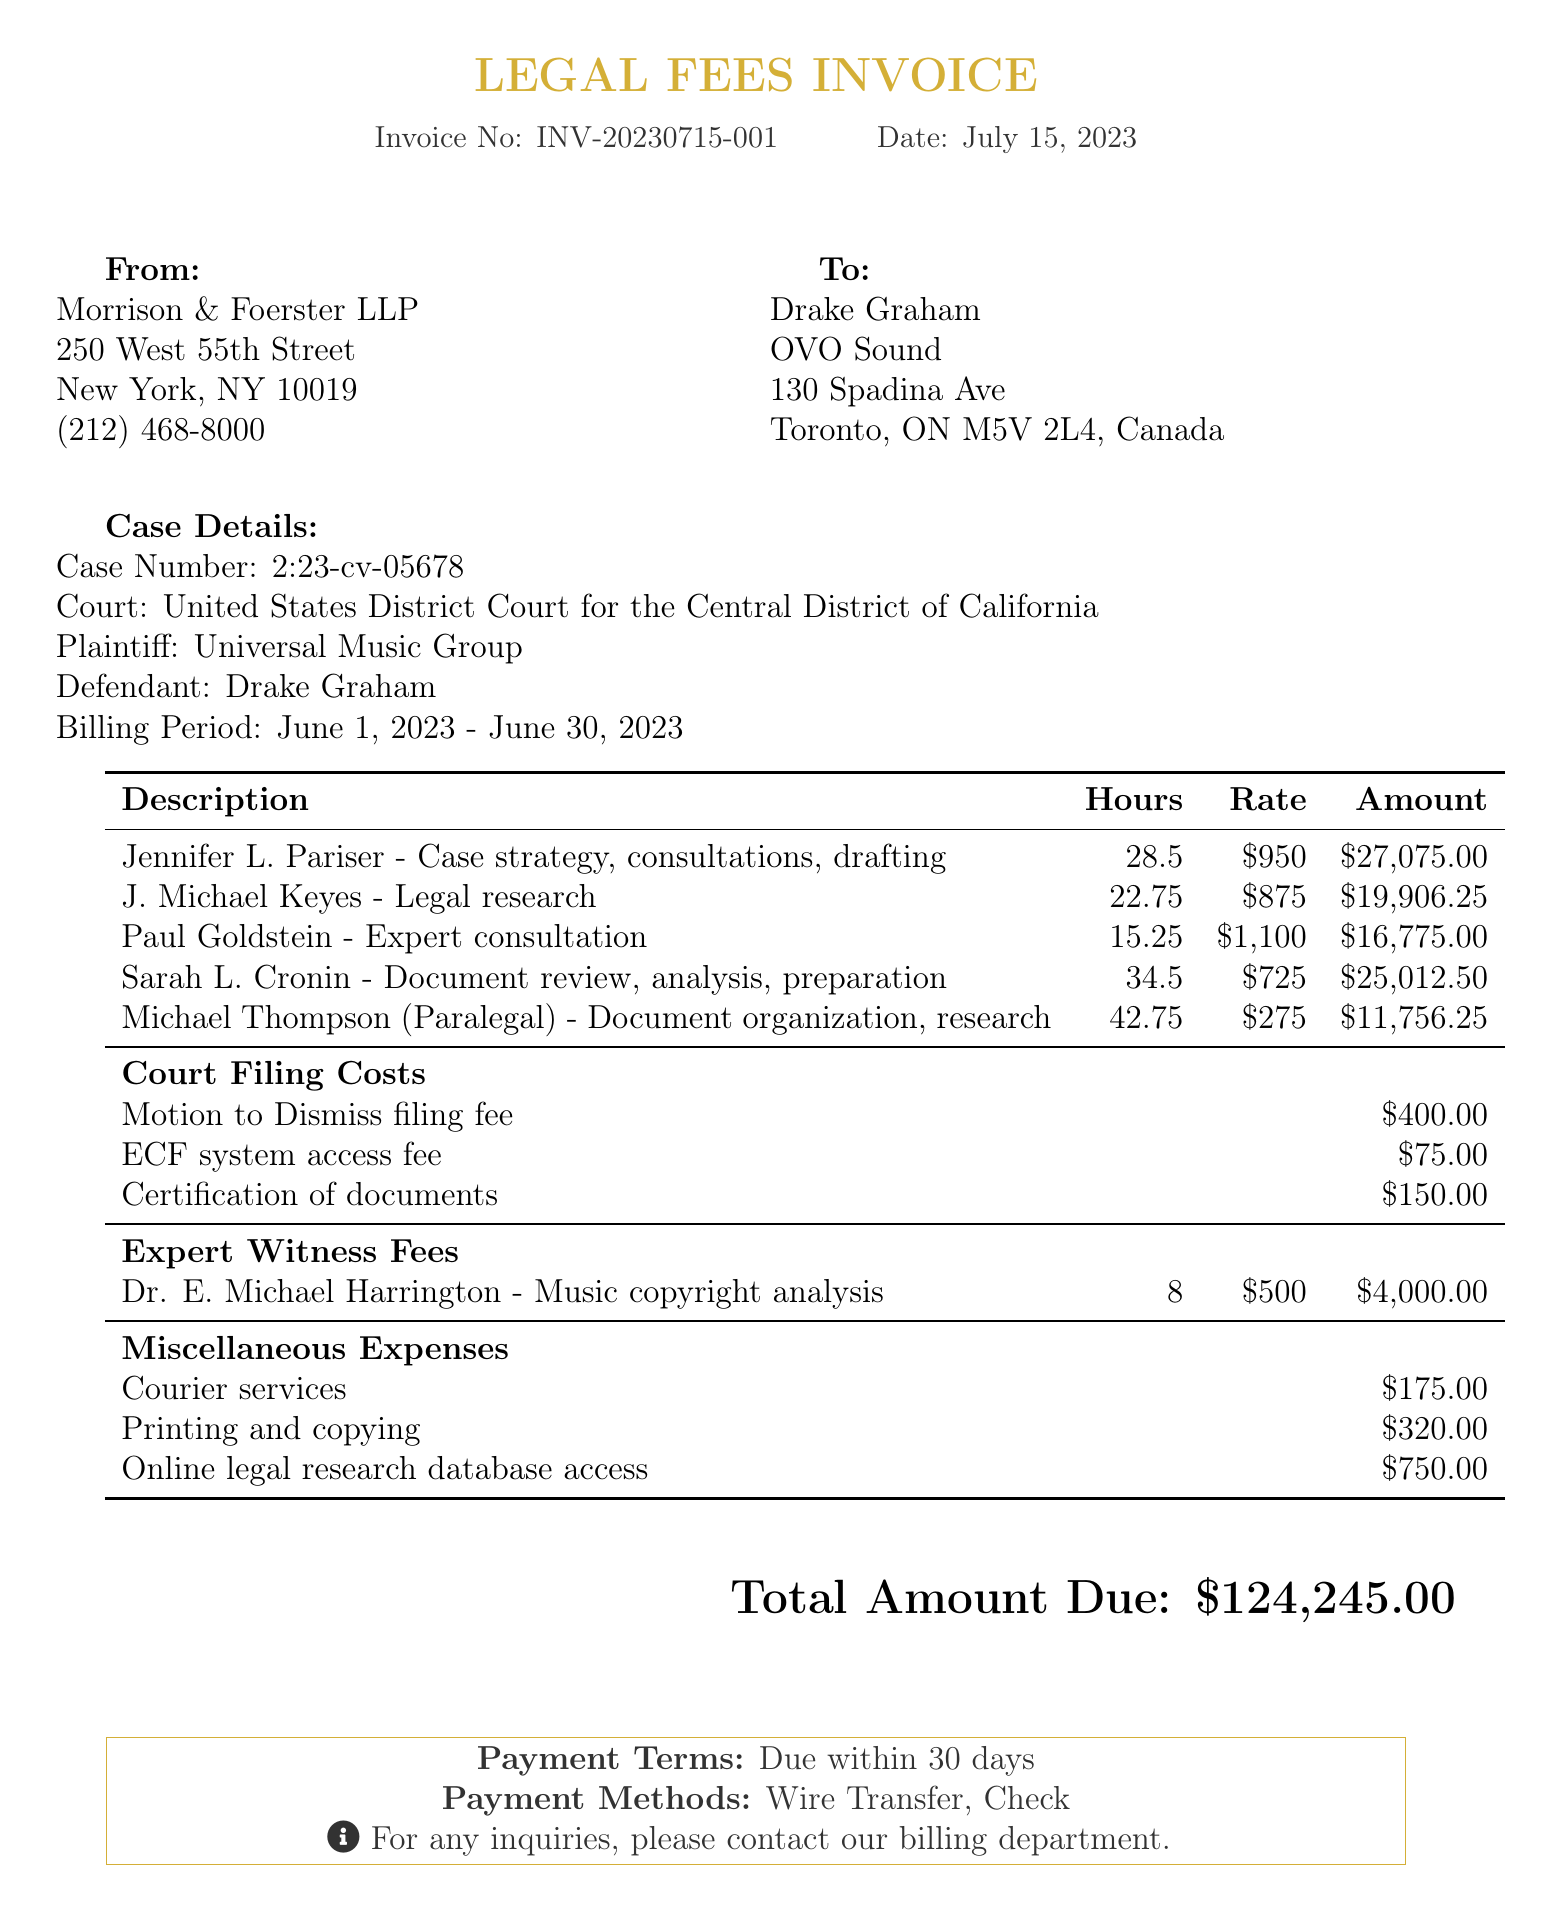What is the invoice number? The invoice number is specified in the document under invoice details.
Answer: INV-20230715-001 What is the date of the invoice? The date of the invoice is provided in the invoice details section.
Answer: July 15, 2023 Who is the plaintiff in this case? The plaintiff is listed in the case details section of the document.
Answer: Universal Music Group What is the total amount due? The total amount due is prominently stated at the end of the document.
Answer: $124,245.00 How many hours did Jennifer L. Pariser work? The hours worked by each attorney are detailed in the attorney hours section.
Answer: 28.5 What is the rate per hour for Sarah L. Cronin? The rate for Sarah L. Cronin is included in the attorney hours section.
Answer: $725 What is the total fee for paralegal Michael Thompson? The total fee is calculated from the hours worked and rate per hour in the paralegal hours section.
Answer: $11,756.25 What is included in the miscellaneous expenses? Miscellaneous expenses are detailed at the end of the attorney hours, specifying various costs.
Answer: Courier services, Printing and copying, Online legal research database access How many hours did the expert witness work? The hours worked by the expert witness are specified in the expert witness fees section of the document.
Answer: 8 